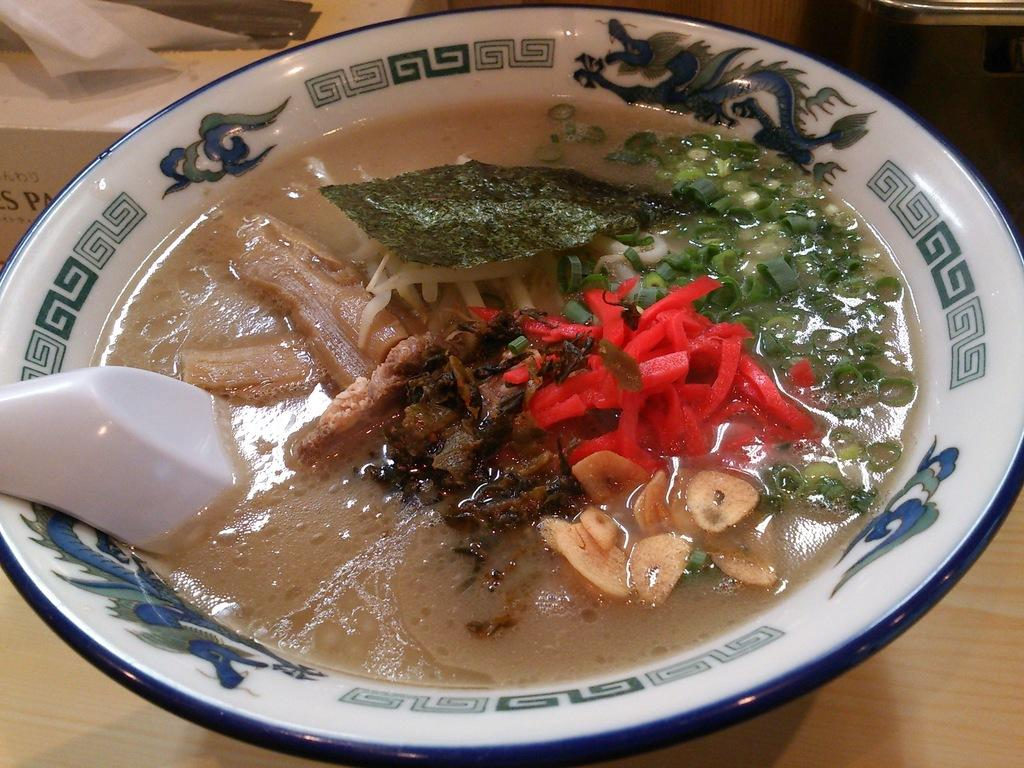What is in the bowl that is visible in the image? There is a bowl with food items in the image. What utensil is placed with the bowl? There is a spoon in the bowl. On what is the bowl placed? The bowl is placed on a table. How does the bowl make people laugh in the image? The bowl does not make people laugh in the image; it is simply a bowl with food items and a spoon. 